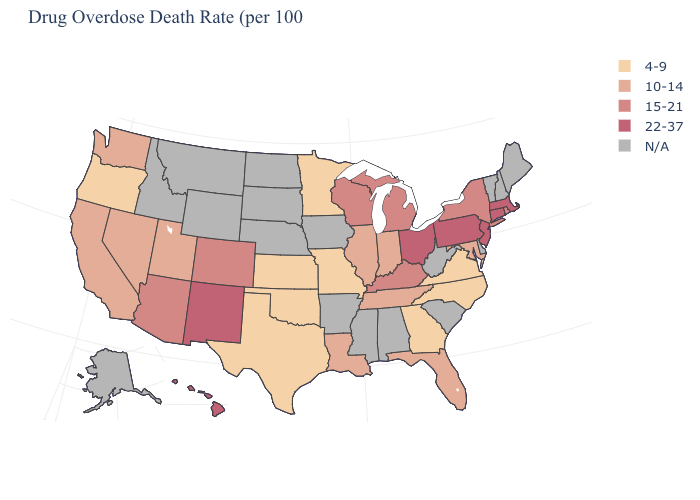How many symbols are there in the legend?
Be succinct. 5. Which states have the highest value in the USA?
Keep it brief. Connecticut, Hawaii, Massachusetts, New Jersey, New Mexico, Ohio, Pennsylvania. What is the value of Kentucky?
Give a very brief answer. 15-21. What is the value of Georgia?
Give a very brief answer. 4-9. What is the value of Indiana?
Short answer required. 10-14. What is the lowest value in the South?
Be succinct. 4-9. Is the legend a continuous bar?
Quick response, please. No. Name the states that have a value in the range 15-21?
Concise answer only. Arizona, Colorado, Kentucky, Michigan, New York, Rhode Island, Wisconsin. What is the value of Nebraska?
Be succinct. N/A. Which states have the lowest value in the USA?
Quick response, please. Georgia, Kansas, Minnesota, Missouri, North Carolina, Oklahoma, Oregon, Texas, Virginia. What is the highest value in states that border North Carolina?
Concise answer only. 10-14. What is the lowest value in the USA?
Short answer required. 4-9. Does the first symbol in the legend represent the smallest category?
Answer briefly. Yes. What is the lowest value in the USA?
Answer briefly. 4-9. 